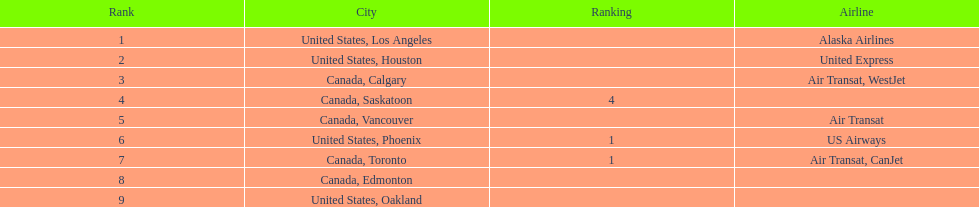Los angeles and what other city had about 19,000 passenger combined Canada, Calgary. 